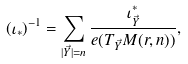Convert formula to latex. <formula><loc_0><loc_0><loc_500><loc_500>( \iota _ { * } ) ^ { - 1 } = \sum _ { | \vec { Y } | = n } \frac { \iota _ { \vec { Y } } ^ { * } } { e ( T _ { \vec { Y } } M ( r , n ) ) } ,</formula> 